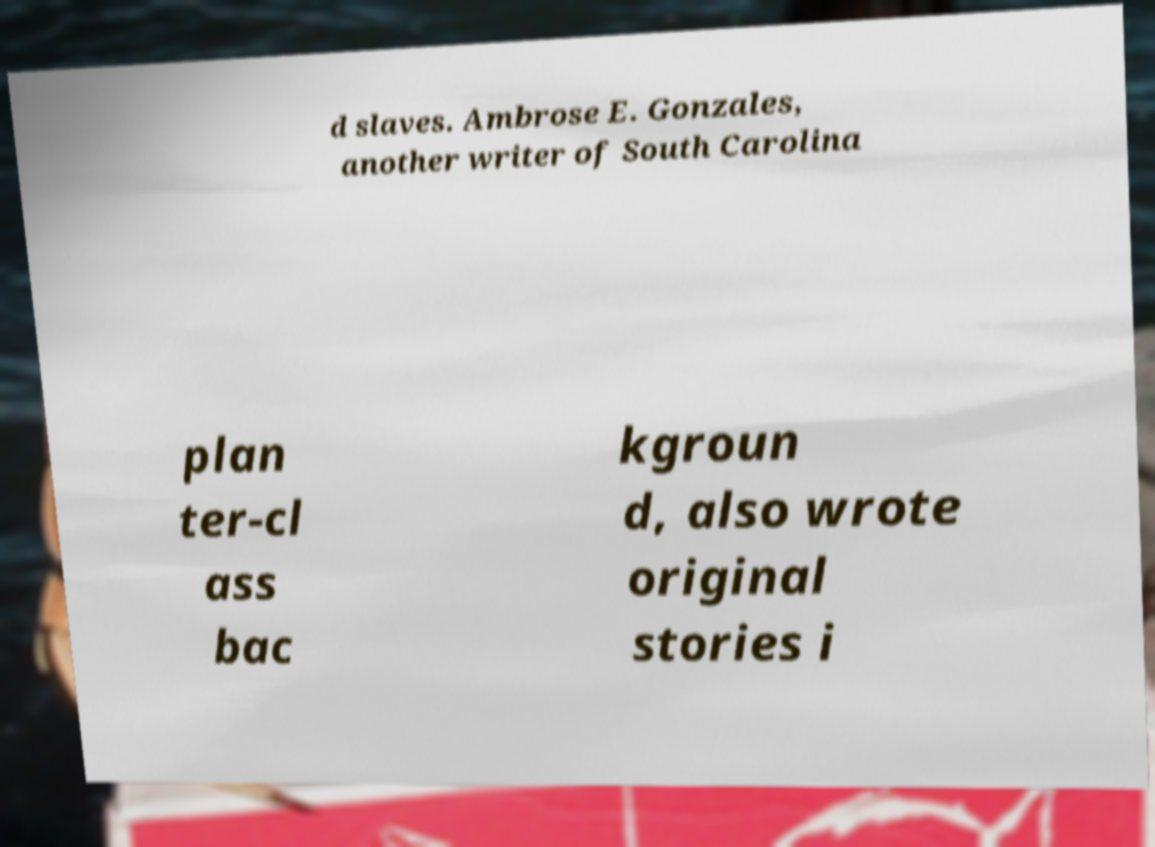For documentation purposes, I need the text within this image transcribed. Could you provide that? d slaves. Ambrose E. Gonzales, another writer of South Carolina plan ter-cl ass bac kgroun d, also wrote original stories i 